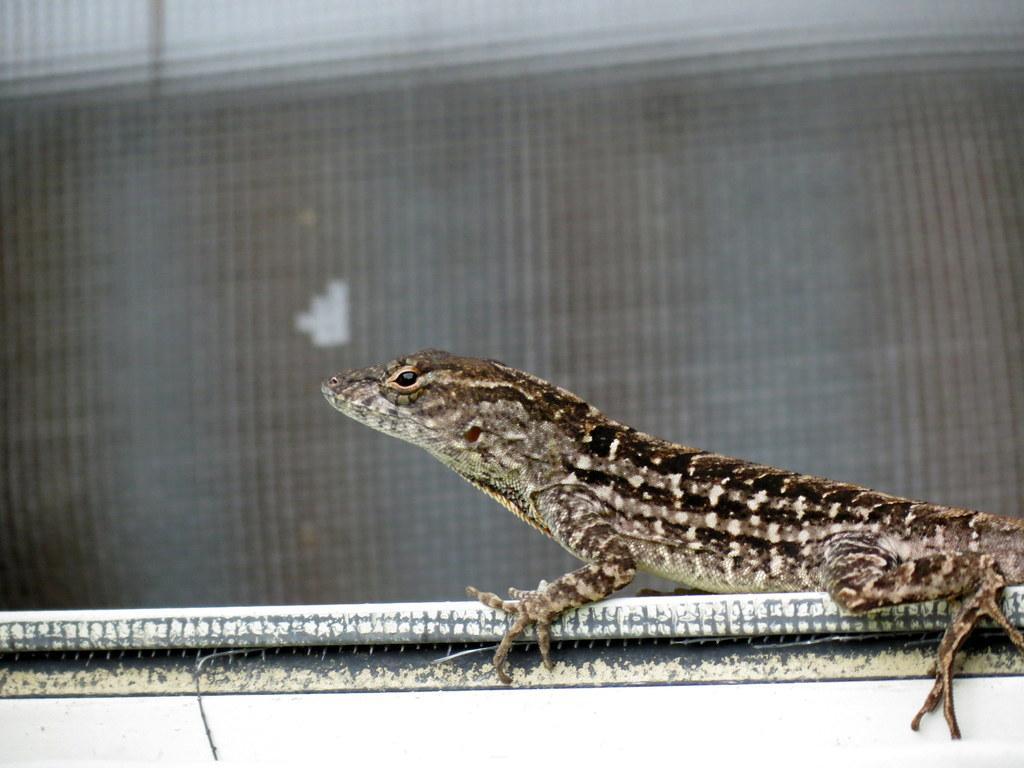Could you give a brief overview of what you see in this image? In this picture we can see a lizard on an object and in the background it is blurry. 